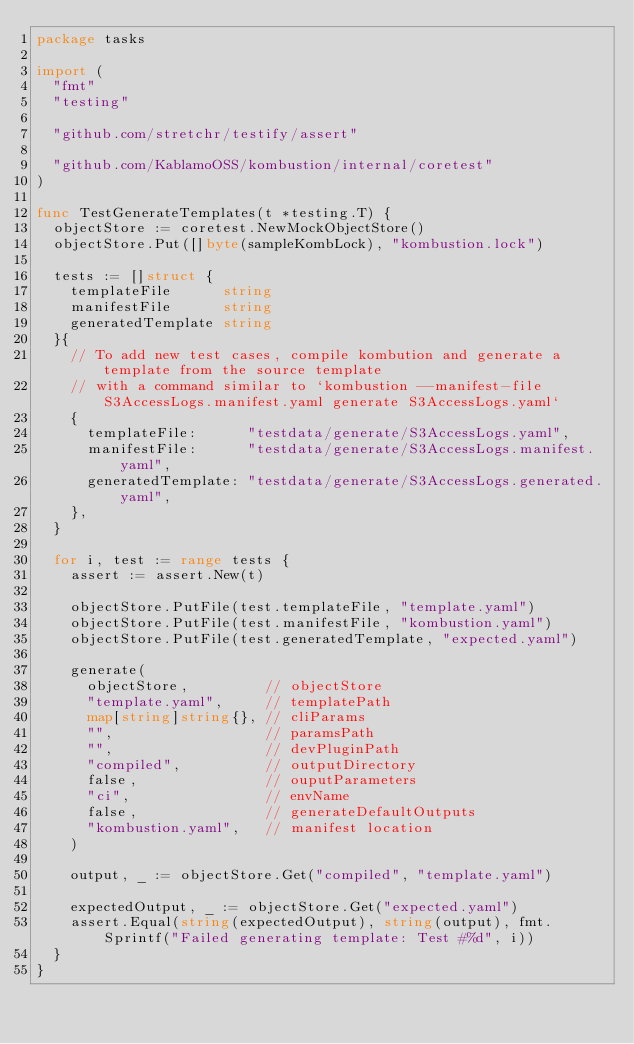Convert code to text. <code><loc_0><loc_0><loc_500><loc_500><_Go_>package tasks

import (
	"fmt"
	"testing"

	"github.com/stretchr/testify/assert"

	"github.com/KablamoOSS/kombustion/internal/coretest"
)

func TestGenerateTemplates(t *testing.T) {
	objectStore := coretest.NewMockObjectStore()
	objectStore.Put([]byte(sampleKombLock), "kombustion.lock")

	tests := []struct {
		templateFile      string
		manifestFile      string
		generatedTemplate string
	}{
		// To add new test cases, compile kombution and generate a template from the source template
		// with a command similar to `kombustion --manifest-file S3AccessLogs.manifest.yaml generate S3AccessLogs.yaml`
		{
			templateFile:      "testdata/generate/S3AccessLogs.yaml",
			manifestFile:      "testdata/generate/S3AccessLogs.manifest.yaml",
			generatedTemplate: "testdata/generate/S3AccessLogs.generated.yaml",
		},
	}

	for i, test := range tests {
		assert := assert.New(t)

		objectStore.PutFile(test.templateFile, "template.yaml")
		objectStore.PutFile(test.manifestFile, "kombustion.yaml")
		objectStore.PutFile(test.generatedTemplate, "expected.yaml")

		generate(
			objectStore,         // objectStore
			"template.yaml",     // templatePath
			map[string]string{}, // cliParams
			"",                  // paramsPath
			"",                  // devPluginPath
			"compiled",          // outputDirectory
			false,               // ouputParameters
			"ci",                // envName
			false,               // generateDefaultOutputs
			"kombustion.yaml",   // manifest location
		)

		output, _ := objectStore.Get("compiled", "template.yaml")

		expectedOutput, _ := objectStore.Get("expected.yaml")
		assert.Equal(string(expectedOutput), string(output), fmt.Sprintf("Failed generating template: Test #%d", i))
	}
}
</code> 